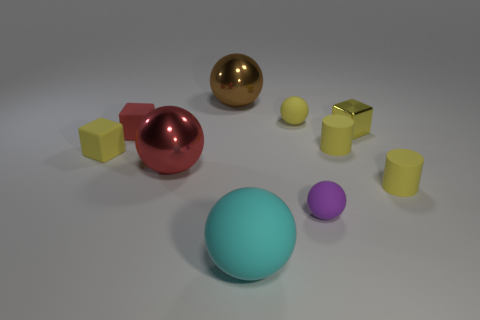Are there fewer matte cylinders behind the red cube than big cyan objects?
Offer a terse response. Yes. The matte sphere behind the purple ball is what color?
Your response must be concise. Yellow. There is a small object behind the yellow block that is on the right side of the cyan matte sphere; what is its material?
Offer a terse response. Rubber. Are there any cyan rubber balls of the same size as the brown metal ball?
Keep it short and to the point. Yes. What number of objects are either things that are to the left of the tiny purple sphere or matte objects that are right of the small purple rubber object?
Offer a terse response. 8. Is the size of the block right of the large cyan thing the same as the shiny object that is to the left of the brown thing?
Make the answer very short. No. Are there any metallic objects to the right of the yellow cube on the right side of the small yellow rubber ball?
Your response must be concise. No. How many rubber spheres are behind the tiny purple rubber thing?
Provide a succinct answer. 1. What number of other objects are there of the same color as the tiny shiny object?
Keep it short and to the point. 4. Is the number of big rubber objects behind the small yellow matte block less than the number of yellow metallic things right of the small red matte block?
Offer a very short reply. Yes. 